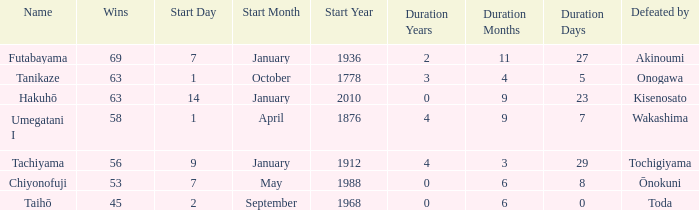How many wins were held before being defeated by toda? 1.0. 